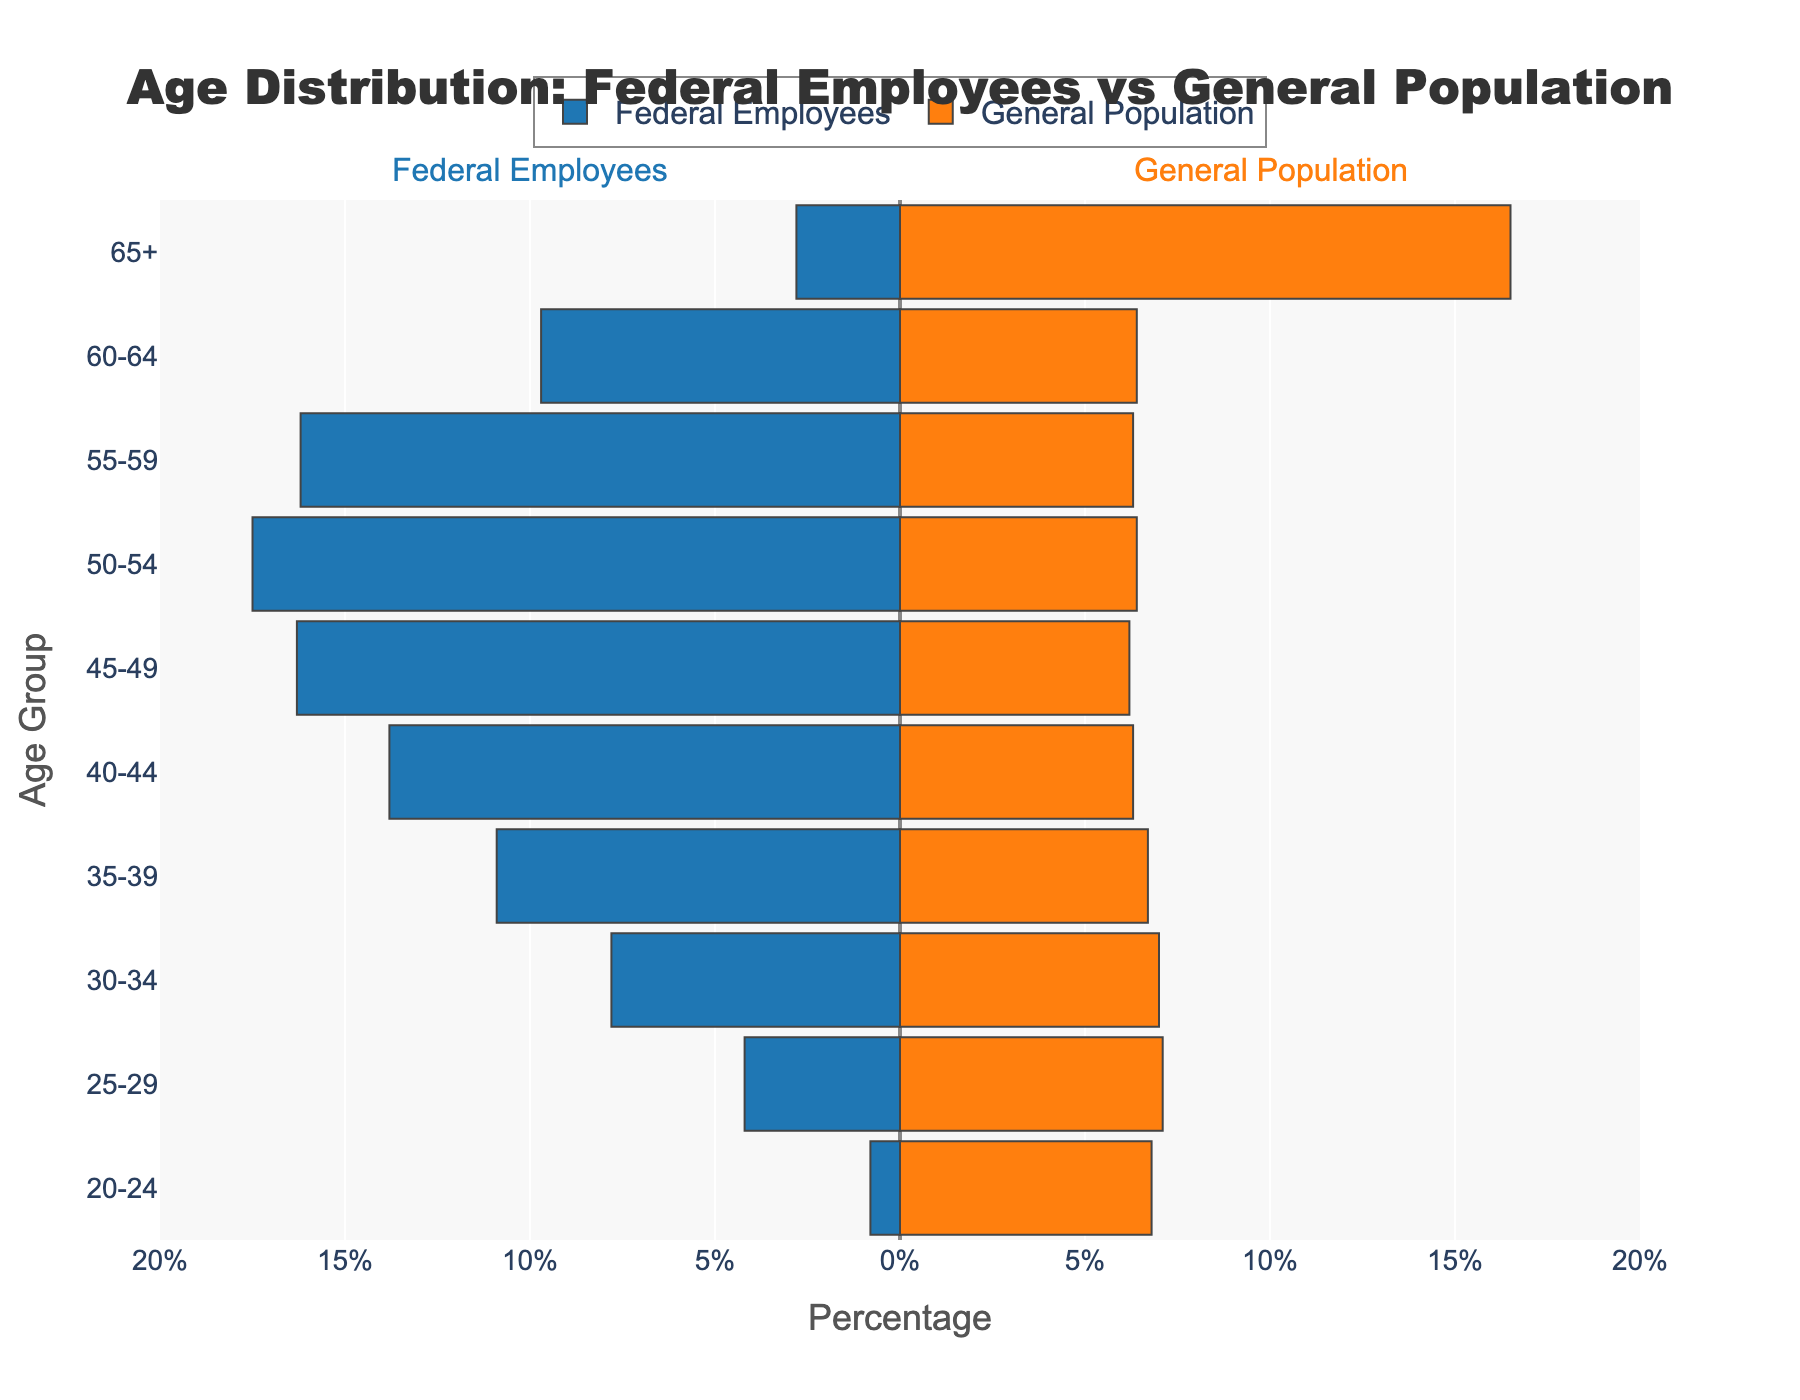what is the title of the figure? The title of the figure is located at the top and describes the subject of the chart. By reading it, we can identify the main purpose of the visualization.
Answer: Age Distribution: Federal Employees vs General Population What age group has the largest percentage of federal employees? To determine this, look for the longest bar on the federal employees’ side (left) of the pyramid. This bar represents the age group with the highest percentage of federal employees.
Answer: 50-54 How does the percentage of federal employees in the 60-64 age group compare to the general population in the same group? Compare the bars corresponding to the 60-64 age group on both sides. The federal employees' percentage is represented by the left bar while the general population is represented by the right bar.
Answer: Higher In which age group is the percentage difference between federal employees and the general population the greatest? Calculate the absolute difference for each age group by subtracting the smaller percentage from the larger one. Identify the group with the maximum absolute difference.
Answer: 50-54 Which age group has the smallest representation among federal employees? Look for the smallest bar among the federal employees' side of the pyramid to find the age group with the lowest percentage.
Answer: 20-24 How many age groups have a higher percentage of federal employees than the general population? Identify and count all the age groups where the bar for federal employees is longer than the one for the general population.
Answer: 8 Is the percentage of the general population higher or lower than federal employees in the 30-34 age group? Compare the bars corresponding to the 30-34 age group in both federal employees and general population categories.
Answer: Higher What is the combined percentage of federal employees in the age groups from 45-49 to 55-59? Sum the percentages of federal employees for the age groups 45-49, 50-54, and 55-59.
Answer: 50.0% Which two consecutive age groups show the largest drop in federal employee percentage? Calculate the percentage drop between consecutive age groups and identify the largest drop.
Answer: 25-29 to 20-24 What general trend can you observe about the age distribution of federal employees compared to the general population? Analyze the overall shape and length of bars on both sides of the pyramid. The age groups can highlight whether federal employees skew older or younger compared to the general population.
Answer: Federal employees skew older 